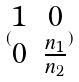Convert formula to latex. <formula><loc_0><loc_0><loc_500><loc_500>( \begin{matrix} 1 & 0 \\ 0 & \frac { n _ { 1 } } { n _ { 2 } } \end{matrix} )</formula> 